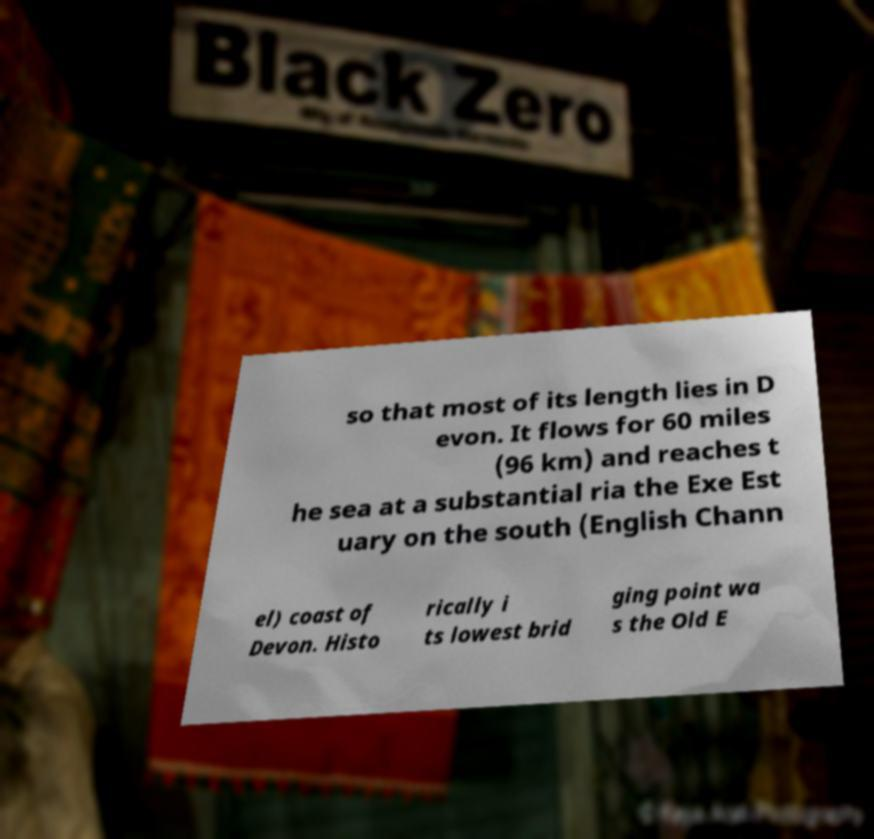Please identify and transcribe the text found in this image. so that most of its length lies in D evon. It flows for 60 miles (96 km) and reaches t he sea at a substantial ria the Exe Est uary on the south (English Chann el) coast of Devon. Histo rically i ts lowest brid ging point wa s the Old E 